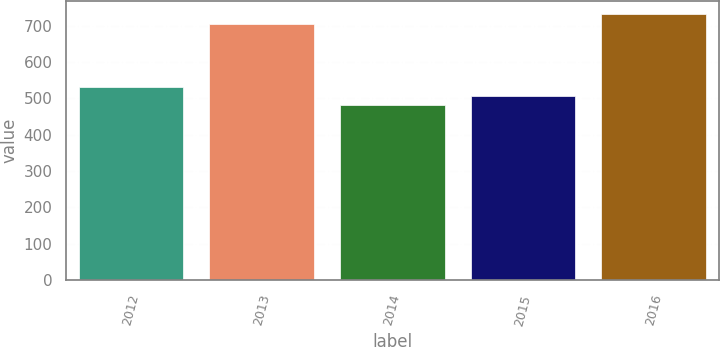Convert chart to OTSL. <chart><loc_0><loc_0><loc_500><loc_500><bar_chart><fcel>2012<fcel>2013<fcel>2014<fcel>2015<fcel>2016<nl><fcel>531<fcel>705<fcel>481<fcel>506<fcel>731<nl></chart> 